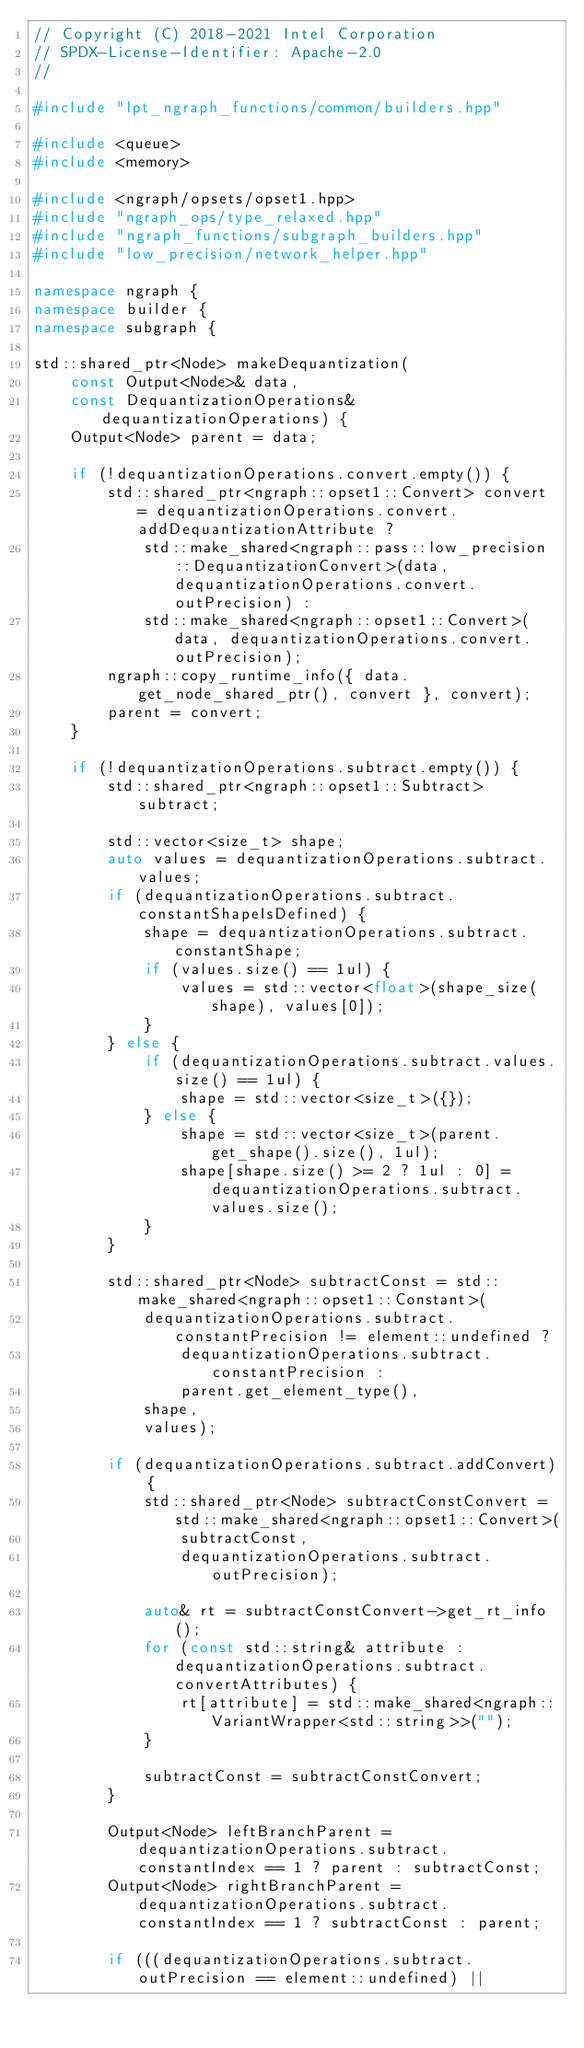Convert code to text. <code><loc_0><loc_0><loc_500><loc_500><_C++_>// Copyright (C) 2018-2021 Intel Corporation
// SPDX-License-Identifier: Apache-2.0
//

#include "lpt_ngraph_functions/common/builders.hpp"

#include <queue>
#include <memory>

#include <ngraph/opsets/opset1.hpp>
#include "ngraph_ops/type_relaxed.hpp"
#include "ngraph_functions/subgraph_builders.hpp"
#include "low_precision/network_helper.hpp"

namespace ngraph {
namespace builder {
namespace subgraph {

std::shared_ptr<Node> makeDequantization(
    const Output<Node>& data,
    const DequantizationOperations& dequantizationOperations) {
    Output<Node> parent = data;

    if (!dequantizationOperations.convert.empty()) {
        std::shared_ptr<ngraph::opset1::Convert> convert = dequantizationOperations.convert.addDequantizationAttribute ?
            std::make_shared<ngraph::pass::low_precision::DequantizationConvert>(data, dequantizationOperations.convert.outPrecision) :
            std::make_shared<ngraph::opset1::Convert>(data, dequantizationOperations.convert.outPrecision);
        ngraph::copy_runtime_info({ data.get_node_shared_ptr(), convert }, convert);
        parent = convert;
    }

    if (!dequantizationOperations.subtract.empty()) {
        std::shared_ptr<ngraph::opset1::Subtract> subtract;

        std::vector<size_t> shape;
        auto values = dequantizationOperations.subtract.values;
        if (dequantizationOperations.subtract.constantShapeIsDefined) {
            shape = dequantizationOperations.subtract.constantShape;
            if (values.size() == 1ul) {
                values = std::vector<float>(shape_size(shape), values[0]);
            }
        } else {
            if (dequantizationOperations.subtract.values.size() == 1ul) {
                shape = std::vector<size_t>({});
            } else {
                shape = std::vector<size_t>(parent.get_shape().size(), 1ul);
                shape[shape.size() >= 2 ? 1ul : 0] = dequantizationOperations.subtract.values.size();
            }
        }

        std::shared_ptr<Node> subtractConst = std::make_shared<ngraph::opset1::Constant>(
            dequantizationOperations.subtract.constantPrecision != element::undefined ?
                dequantizationOperations.subtract.constantPrecision :
                parent.get_element_type(),
            shape,
            values);

        if (dequantizationOperations.subtract.addConvert) {
            std::shared_ptr<Node> subtractConstConvert = std::make_shared<ngraph::opset1::Convert>(
                subtractConst,
                dequantizationOperations.subtract.outPrecision);

            auto& rt = subtractConstConvert->get_rt_info();
            for (const std::string& attribute : dequantizationOperations.subtract.convertAttributes) {
                rt[attribute] = std::make_shared<ngraph::VariantWrapper<std::string>>("");
            }

            subtractConst = subtractConstConvert;
        }

        Output<Node> leftBranchParent = dequantizationOperations.subtract.constantIndex == 1 ? parent : subtractConst;
        Output<Node> rightBranchParent = dequantizationOperations.subtract.constantIndex == 1 ? subtractConst : parent;

        if (((dequantizationOperations.subtract.outPrecision == element::undefined) ||</code> 